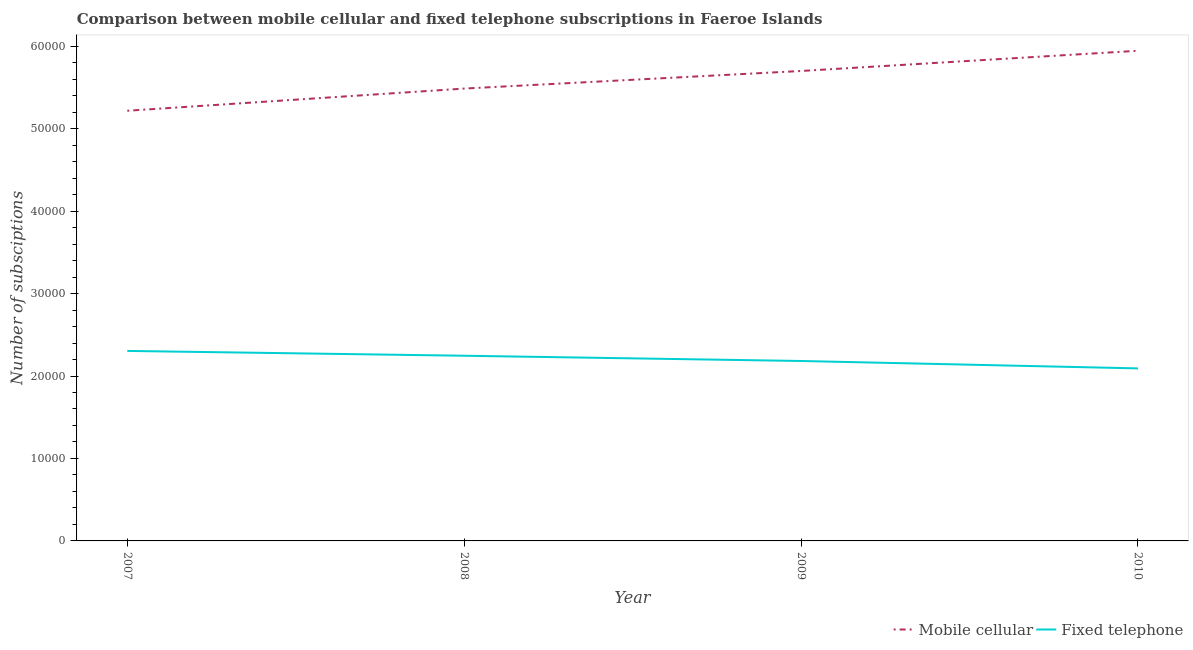How many different coloured lines are there?
Your response must be concise. 2. What is the number of fixed telephone subscriptions in 2008?
Keep it short and to the point. 2.25e+04. Across all years, what is the maximum number of mobile cellular subscriptions?
Offer a very short reply. 5.94e+04. Across all years, what is the minimum number of mobile cellular subscriptions?
Give a very brief answer. 5.22e+04. In which year was the number of fixed telephone subscriptions maximum?
Your response must be concise. 2007. What is the total number of fixed telephone subscriptions in the graph?
Your answer should be compact. 8.82e+04. What is the difference between the number of fixed telephone subscriptions in 2007 and that in 2008?
Ensure brevity in your answer.  584. What is the difference between the number of fixed telephone subscriptions in 2007 and the number of mobile cellular subscriptions in 2009?
Give a very brief answer. -3.40e+04. What is the average number of fixed telephone subscriptions per year?
Your response must be concise. 2.21e+04. In the year 2010, what is the difference between the number of fixed telephone subscriptions and number of mobile cellular subscriptions?
Provide a succinct answer. -3.85e+04. What is the ratio of the number of fixed telephone subscriptions in 2008 to that in 2010?
Make the answer very short. 1.07. Is the number of mobile cellular subscriptions in 2008 less than that in 2009?
Keep it short and to the point. Yes. What is the difference between the highest and the second highest number of fixed telephone subscriptions?
Ensure brevity in your answer.  584. What is the difference between the highest and the lowest number of fixed telephone subscriptions?
Your answer should be very brief. 2119. In how many years, is the number of fixed telephone subscriptions greater than the average number of fixed telephone subscriptions taken over all years?
Your response must be concise. 2. Does the number of mobile cellular subscriptions monotonically increase over the years?
Offer a very short reply. Yes. Is the number of mobile cellular subscriptions strictly greater than the number of fixed telephone subscriptions over the years?
Your answer should be very brief. Yes. Is the number of fixed telephone subscriptions strictly less than the number of mobile cellular subscriptions over the years?
Your answer should be compact. Yes. How many lines are there?
Ensure brevity in your answer.  2. What is the difference between two consecutive major ticks on the Y-axis?
Ensure brevity in your answer.  10000. How are the legend labels stacked?
Your answer should be very brief. Horizontal. What is the title of the graph?
Provide a succinct answer. Comparison between mobile cellular and fixed telephone subscriptions in Faeroe Islands. Does "Taxes on exports" appear as one of the legend labels in the graph?
Your response must be concise. No. What is the label or title of the X-axis?
Provide a short and direct response. Year. What is the label or title of the Y-axis?
Offer a terse response. Number of subsciptions. What is the Number of subsciptions of Mobile cellular in 2007?
Your answer should be very brief. 5.22e+04. What is the Number of subsciptions of Fixed telephone in 2007?
Provide a short and direct response. 2.30e+04. What is the Number of subsciptions of Mobile cellular in 2008?
Provide a short and direct response. 5.49e+04. What is the Number of subsciptions of Fixed telephone in 2008?
Ensure brevity in your answer.  2.25e+04. What is the Number of subsciptions of Mobile cellular in 2009?
Keep it short and to the point. 5.70e+04. What is the Number of subsciptions in Fixed telephone in 2009?
Offer a very short reply. 2.18e+04. What is the Number of subsciptions of Mobile cellular in 2010?
Make the answer very short. 5.94e+04. What is the Number of subsciptions in Fixed telephone in 2010?
Your answer should be very brief. 2.09e+04. Across all years, what is the maximum Number of subsciptions of Mobile cellular?
Provide a short and direct response. 5.94e+04. Across all years, what is the maximum Number of subsciptions of Fixed telephone?
Your answer should be compact. 2.30e+04. Across all years, what is the minimum Number of subsciptions in Mobile cellular?
Ensure brevity in your answer.  5.22e+04. Across all years, what is the minimum Number of subsciptions of Fixed telephone?
Your answer should be very brief. 2.09e+04. What is the total Number of subsciptions in Mobile cellular in the graph?
Your answer should be very brief. 2.23e+05. What is the total Number of subsciptions of Fixed telephone in the graph?
Provide a short and direct response. 8.82e+04. What is the difference between the Number of subsciptions in Mobile cellular in 2007 and that in 2008?
Keep it short and to the point. -2691. What is the difference between the Number of subsciptions in Fixed telephone in 2007 and that in 2008?
Your answer should be compact. 584. What is the difference between the Number of subsciptions of Mobile cellular in 2007 and that in 2009?
Your answer should be very brief. -4824. What is the difference between the Number of subsciptions of Fixed telephone in 2007 and that in 2009?
Keep it short and to the point. 1221. What is the difference between the Number of subsciptions of Mobile cellular in 2007 and that in 2010?
Ensure brevity in your answer.  -7277. What is the difference between the Number of subsciptions of Fixed telephone in 2007 and that in 2010?
Give a very brief answer. 2119. What is the difference between the Number of subsciptions in Mobile cellular in 2008 and that in 2009?
Give a very brief answer. -2133. What is the difference between the Number of subsciptions of Fixed telephone in 2008 and that in 2009?
Offer a very short reply. 637. What is the difference between the Number of subsciptions in Mobile cellular in 2008 and that in 2010?
Offer a very short reply. -4586. What is the difference between the Number of subsciptions in Fixed telephone in 2008 and that in 2010?
Offer a very short reply. 1535. What is the difference between the Number of subsciptions in Mobile cellular in 2009 and that in 2010?
Your response must be concise. -2453. What is the difference between the Number of subsciptions in Fixed telephone in 2009 and that in 2010?
Ensure brevity in your answer.  898. What is the difference between the Number of subsciptions of Mobile cellular in 2007 and the Number of subsciptions of Fixed telephone in 2008?
Provide a succinct answer. 2.97e+04. What is the difference between the Number of subsciptions in Mobile cellular in 2007 and the Number of subsciptions in Fixed telephone in 2009?
Provide a succinct answer. 3.03e+04. What is the difference between the Number of subsciptions of Mobile cellular in 2007 and the Number of subsciptions of Fixed telephone in 2010?
Provide a succinct answer. 3.12e+04. What is the difference between the Number of subsciptions in Mobile cellular in 2008 and the Number of subsciptions in Fixed telephone in 2009?
Provide a short and direct response. 3.30e+04. What is the difference between the Number of subsciptions of Mobile cellular in 2008 and the Number of subsciptions of Fixed telephone in 2010?
Provide a short and direct response. 3.39e+04. What is the difference between the Number of subsciptions of Mobile cellular in 2009 and the Number of subsciptions of Fixed telephone in 2010?
Offer a very short reply. 3.61e+04. What is the average Number of subsciptions of Mobile cellular per year?
Keep it short and to the point. 5.59e+04. What is the average Number of subsciptions of Fixed telephone per year?
Keep it short and to the point. 2.21e+04. In the year 2007, what is the difference between the Number of subsciptions in Mobile cellular and Number of subsciptions in Fixed telephone?
Offer a very short reply. 2.91e+04. In the year 2008, what is the difference between the Number of subsciptions in Mobile cellular and Number of subsciptions in Fixed telephone?
Make the answer very short. 3.24e+04. In the year 2009, what is the difference between the Number of subsciptions in Mobile cellular and Number of subsciptions in Fixed telephone?
Provide a succinct answer. 3.52e+04. In the year 2010, what is the difference between the Number of subsciptions in Mobile cellular and Number of subsciptions in Fixed telephone?
Provide a short and direct response. 3.85e+04. What is the ratio of the Number of subsciptions of Mobile cellular in 2007 to that in 2008?
Provide a short and direct response. 0.95. What is the ratio of the Number of subsciptions in Fixed telephone in 2007 to that in 2008?
Provide a short and direct response. 1.03. What is the ratio of the Number of subsciptions in Mobile cellular in 2007 to that in 2009?
Your answer should be compact. 0.92. What is the ratio of the Number of subsciptions in Fixed telephone in 2007 to that in 2009?
Give a very brief answer. 1.06. What is the ratio of the Number of subsciptions of Mobile cellular in 2007 to that in 2010?
Give a very brief answer. 0.88. What is the ratio of the Number of subsciptions of Fixed telephone in 2007 to that in 2010?
Provide a short and direct response. 1.1. What is the ratio of the Number of subsciptions of Mobile cellular in 2008 to that in 2009?
Your answer should be very brief. 0.96. What is the ratio of the Number of subsciptions of Fixed telephone in 2008 to that in 2009?
Your answer should be very brief. 1.03. What is the ratio of the Number of subsciptions in Mobile cellular in 2008 to that in 2010?
Make the answer very short. 0.92. What is the ratio of the Number of subsciptions of Fixed telephone in 2008 to that in 2010?
Offer a terse response. 1.07. What is the ratio of the Number of subsciptions of Mobile cellular in 2009 to that in 2010?
Ensure brevity in your answer.  0.96. What is the ratio of the Number of subsciptions of Fixed telephone in 2009 to that in 2010?
Ensure brevity in your answer.  1.04. What is the difference between the highest and the second highest Number of subsciptions of Mobile cellular?
Your answer should be very brief. 2453. What is the difference between the highest and the second highest Number of subsciptions of Fixed telephone?
Give a very brief answer. 584. What is the difference between the highest and the lowest Number of subsciptions of Mobile cellular?
Offer a very short reply. 7277. What is the difference between the highest and the lowest Number of subsciptions of Fixed telephone?
Keep it short and to the point. 2119. 